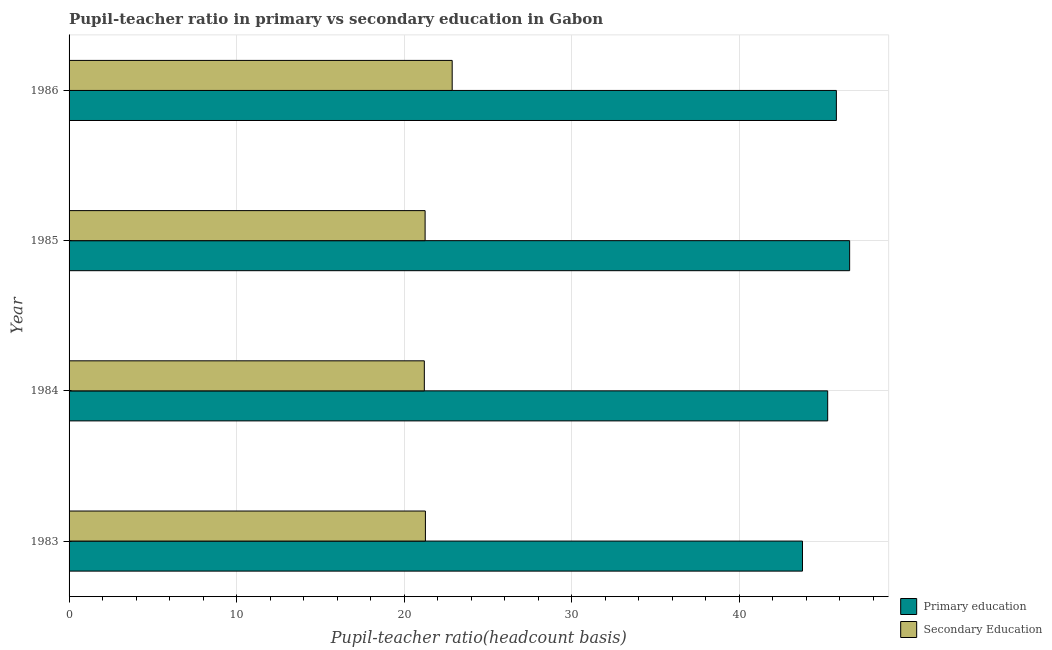How many different coloured bars are there?
Your answer should be very brief. 2. Are the number of bars on each tick of the Y-axis equal?
Your response must be concise. Yes. How many bars are there on the 4th tick from the top?
Make the answer very short. 2. What is the pupil teacher ratio on secondary education in 1985?
Provide a succinct answer. 21.26. Across all years, what is the maximum pupil-teacher ratio in primary education?
Provide a succinct answer. 46.6. Across all years, what is the minimum pupil teacher ratio on secondary education?
Keep it short and to the point. 21.21. What is the total pupil teacher ratio on secondary education in the graph?
Give a very brief answer. 86.62. What is the difference between the pupil-teacher ratio in primary education in 1983 and that in 1985?
Make the answer very short. -2.81. What is the difference between the pupil teacher ratio on secondary education in 1985 and the pupil-teacher ratio in primary education in 1983?
Your answer should be very brief. -22.53. What is the average pupil-teacher ratio in primary education per year?
Provide a succinct answer. 45.37. In the year 1985, what is the difference between the pupil teacher ratio on secondary education and pupil-teacher ratio in primary education?
Provide a short and direct response. -25.35. What is the ratio of the pupil-teacher ratio in primary education in 1983 to that in 1986?
Ensure brevity in your answer.  0.96. What is the difference between the highest and the second highest pupil teacher ratio on secondary education?
Ensure brevity in your answer.  1.6. What is the difference between the highest and the lowest pupil teacher ratio on secondary education?
Offer a very short reply. 1.66. In how many years, is the pupil teacher ratio on secondary education greater than the average pupil teacher ratio on secondary education taken over all years?
Provide a short and direct response. 1. Is the sum of the pupil-teacher ratio in primary education in 1983 and 1984 greater than the maximum pupil teacher ratio on secondary education across all years?
Make the answer very short. Yes. What does the 2nd bar from the top in 1983 represents?
Provide a short and direct response. Primary education. What does the 2nd bar from the bottom in 1984 represents?
Keep it short and to the point. Secondary Education. Are all the bars in the graph horizontal?
Make the answer very short. Yes. Are the values on the major ticks of X-axis written in scientific E-notation?
Ensure brevity in your answer.  No. Does the graph contain any zero values?
Provide a succinct answer. No. Does the graph contain grids?
Ensure brevity in your answer.  Yes. Where does the legend appear in the graph?
Provide a short and direct response. Bottom right. How many legend labels are there?
Offer a very short reply. 2. What is the title of the graph?
Ensure brevity in your answer.  Pupil-teacher ratio in primary vs secondary education in Gabon. Does "By country of asylum" appear as one of the legend labels in the graph?
Offer a very short reply. No. What is the label or title of the X-axis?
Your response must be concise. Pupil-teacher ratio(headcount basis). What is the Pupil-teacher ratio(headcount basis) of Primary education in 1983?
Your response must be concise. 43.79. What is the Pupil-teacher ratio(headcount basis) of Secondary Education in 1983?
Your answer should be compact. 21.27. What is the Pupil-teacher ratio(headcount basis) of Primary education in 1984?
Your answer should be very brief. 45.29. What is the Pupil-teacher ratio(headcount basis) in Secondary Education in 1984?
Keep it short and to the point. 21.21. What is the Pupil-teacher ratio(headcount basis) of Primary education in 1985?
Provide a succinct answer. 46.6. What is the Pupil-teacher ratio(headcount basis) of Secondary Education in 1985?
Your answer should be very brief. 21.26. What is the Pupil-teacher ratio(headcount basis) of Primary education in 1986?
Make the answer very short. 45.81. What is the Pupil-teacher ratio(headcount basis) of Secondary Education in 1986?
Provide a short and direct response. 22.87. Across all years, what is the maximum Pupil-teacher ratio(headcount basis) of Primary education?
Your answer should be compact. 46.6. Across all years, what is the maximum Pupil-teacher ratio(headcount basis) in Secondary Education?
Your answer should be compact. 22.87. Across all years, what is the minimum Pupil-teacher ratio(headcount basis) in Primary education?
Ensure brevity in your answer.  43.79. Across all years, what is the minimum Pupil-teacher ratio(headcount basis) in Secondary Education?
Your answer should be compact. 21.21. What is the total Pupil-teacher ratio(headcount basis) in Primary education in the graph?
Make the answer very short. 181.49. What is the total Pupil-teacher ratio(headcount basis) in Secondary Education in the graph?
Make the answer very short. 86.62. What is the difference between the Pupil-teacher ratio(headcount basis) of Primary education in 1983 and that in 1984?
Keep it short and to the point. -1.51. What is the difference between the Pupil-teacher ratio(headcount basis) of Secondary Education in 1983 and that in 1984?
Your answer should be very brief. 0.06. What is the difference between the Pupil-teacher ratio(headcount basis) in Primary education in 1983 and that in 1985?
Make the answer very short. -2.82. What is the difference between the Pupil-teacher ratio(headcount basis) of Secondary Education in 1983 and that in 1985?
Offer a very short reply. 0.02. What is the difference between the Pupil-teacher ratio(headcount basis) of Primary education in 1983 and that in 1986?
Give a very brief answer. -2.02. What is the difference between the Pupil-teacher ratio(headcount basis) of Secondary Education in 1983 and that in 1986?
Offer a very short reply. -1.6. What is the difference between the Pupil-teacher ratio(headcount basis) of Primary education in 1984 and that in 1985?
Ensure brevity in your answer.  -1.31. What is the difference between the Pupil-teacher ratio(headcount basis) in Secondary Education in 1984 and that in 1985?
Keep it short and to the point. -0.05. What is the difference between the Pupil-teacher ratio(headcount basis) in Primary education in 1984 and that in 1986?
Offer a very short reply. -0.52. What is the difference between the Pupil-teacher ratio(headcount basis) of Secondary Education in 1984 and that in 1986?
Provide a short and direct response. -1.66. What is the difference between the Pupil-teacher ratio(headcount basis) of Primary education in 1985 and that in 1986?
Give a very brief answer. 0.79. What is the difference between the Pupil-teacher ratio(headcount basis) in Secondary Education in 1985 and that in 1986?
Ensure brevity in your answer.  -1.62. What is the difference between the Pupil-teacher ratio(headcount basis) in Primary education in 1983 and the Pupil-teacher ratio(headcount basis) in Secondary Education in 1984?
Provide a short and direct response. 22.58. What is the difference between the Pupil-teacher ratio(headcount basis) in Primary education in 1983 and the Pupil-teacher ratio(headcount basis) in Secondary Education in 1985?
Ensure brevity in your answer.  22.53. What is the difference between the Pupil-teacher ratio(headcount basis) of Primary education in 1983 and the Pupil-teacher ratio(headcount basis) of Secondary Education in 1986?
Keep it short and to the point. 20.91. What is the difference between the Pupil-teacher ratio(headcount basis) of Primary education in 1984 and the Pupil-teacher ratio(headcount basis) of Secondary Education in 1985?
Your answer should be very brief. 24.04. What is the difference between the Pupil-teacher ratio(headcount basis) in Primary education in 1984 and the Pupil-teacher ratio(headcount basis) in Secondary Education in 1986?
Your response must be concise. 22.42. What is the difference between the Pupil-teacher ratio(headcount basis) in Primary education in 1985 and the Pupil-teacher ratio(headcount basis) in Secondary Education in 1986?
Make the answer very short. 23.73. What is the average Pupil-teacher ratio(headcount basis) in Primary education per year?
Give a very brief answer. 45.37. What is the average Pupil-teacher ratio(headcount basis) in Secondary Education per year?
Your answer should be compact. 21.65. In the year 1983, what is the difference between the Pupil-teacher ratio(headcount basis) of Primary education and Pupil-teacher ratio(headcount basis) of Secondary Education?
Provide a short and direct response. 22.51. In the year 1984, what is the difference between the Pupil-teacher ratio(headcount basis) in Primary education and Pupil-teacher ratio(headcount basis) in Secondary Education?
Ensure brevity in your answer.  24.08. In the year 1985, what is the difference between the Pupil-teacher ratio(headcount basis) in Primary education and Pupil-teacher ratio(headcount basis) in Secondary Education?
Your answer should be compact. 25.35. In the year 1986, what is the difference between the Pupil-teacher ratio(headcount basis) of Primary education and Pupil-teacher ratio(headcount basis) of Secondary Education?
Give a very brief answer. 22.94. What is the ratio of the Pupil-teacher ratio(headcount basis) in Primary education in 1983 to that in 1984?
Your answer should be very brief. 0.97. What is the ratio of the Pupil-teacher ratio(headcount basis) in Primary education in 1983 to that in 1985?
Your answer should be compact. 0.94. What is the ratio of the Pupil-teacher ratio(headcount basis) in Secondary Education in 1983 to that in 1985?
Provide a short and direct response. 1. What is the ratio of the Pupil-teacher ratio(headcount basis) of Primary education in 1983 to that in 1986?
Your answer should be very brief. 0.96. What is the ratio of the Pupil-teacher ratio(headcount basis) of Secondary Education in 1983 to that in 1986?
Your answer should be very brief. 0.93. What is the ratio of the Pupil-teacher ratio(headcount basis) of Primary education in 1984 to that in 1985?
Offer a very short reply. 0.97. What is the ratio of the Pupil-teacher ratio(headcount basis) of Secondary Education in 1984 to that in 1985?
Your response must be concise. 1. What is the ratio of the Pupil-teacher ratio(headcount basis) in Primary education in 1984 to that in 1986?
Your response must be concise. 0.99. What is the ratio of the Pupil-teacher ratio(headcount basis) in Secondary Education in 1984 to that in 1986?
Keep it short and to the point. 0.93. What is the ratio of the Pupil-teacher ratio(headcount basis) of Primary education in 1985 to that in 1986?
Provide a short and direct response. 1.02. What is the ratio of the Pupil-teacher ratio(headcount basis) of Secondary Education in 1985 to that in 1986?
Your response must be concise. 0.93. What is the difference between the highest and the second highest Pupil-teacher ratio(headcount basis) of Primary education?
Make the answer very short. 0.79. What is the difference between the highest and the second highest Pupil-teacher ratio(headcount basis) of Secondary Education?
Ensure brevity in your answer.  1.6. What is the difference between the highest and the lowest Pupil-teacher ratio(headcount basis) in Primary education?
Make the answer very short. 2.82. What is the difference between the highest and the lowest Pupil-teacher ratio(headcount basis) in Secondary Education?
Your answer should be very brief. 1.66. 